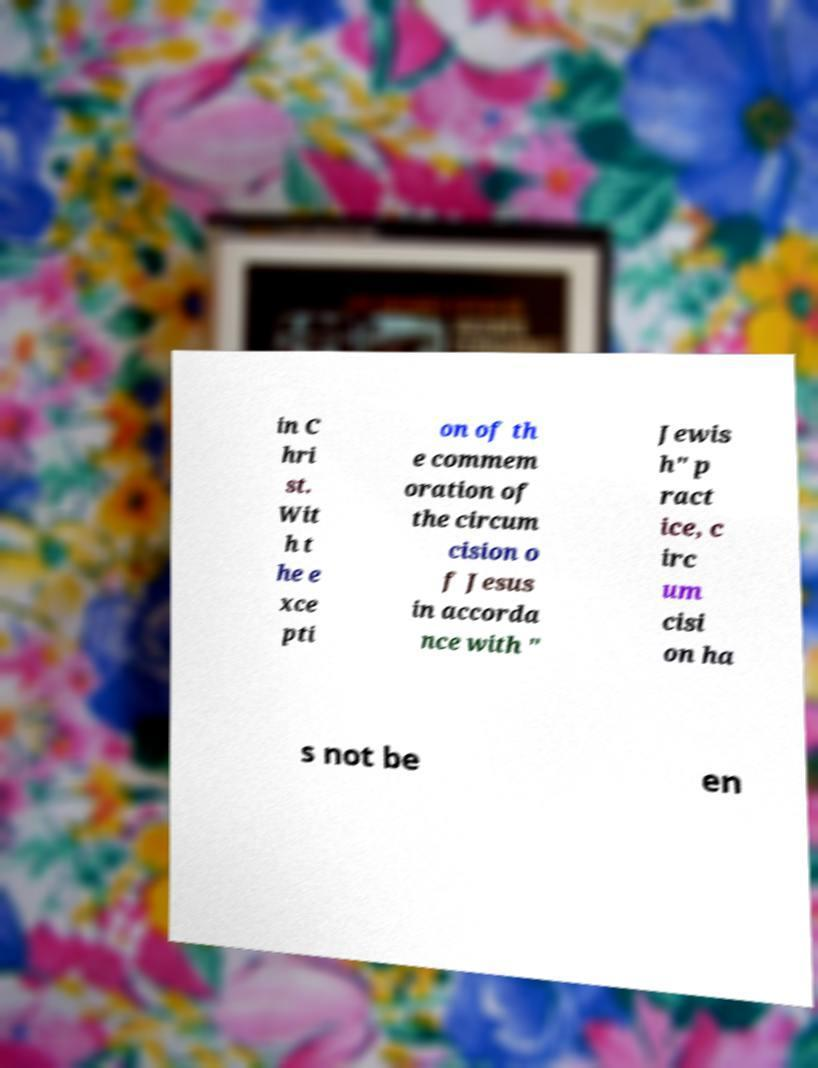I need the written content from this picture converted into text. Can you do that? in C hri st. Wit h t he e xce pti on of th e commem oration of the circum cision o f Jesus in accorda nce with " Jewis h" p ract ice, c irc um cisi on ha s not be en 